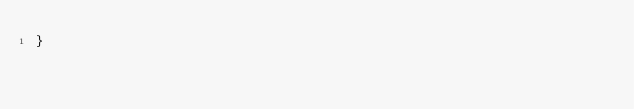Convert code to text. <code><loc_0><loc_0><loc_500><loc_500><_C_>}
</code> 